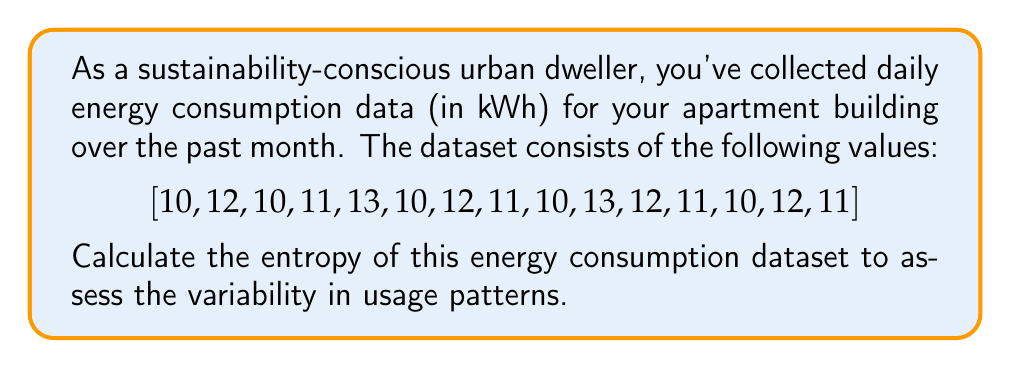Solve this math problem. To calculate the entropy of the energy consumption dataset, we'll follow these steps:

1. Count the frequency of each unique value in the dataset.
2. Calculate the probability of each unique value.
3. Apply the entropy formula.

Step 1: Frequency count
10 kWh: 5 times
11 kWh: 3 times
12 kWh: 4 times
13 kWh: 2 times

Total number of data points: 15

Step 2: Probability calculation
$p(10) = 5/15 = 1/3$
$p(11) = 3/15 = 1/5$
$p(12) = 4/15 = 4/15$
$p(13) = 2/15$

Step 3: Entropy calculation
The entropy formula is:

$$ H = -\sum_{i=1}^{n} p(x_i) \log_2(p(x_i)) $$

Where $p(x_i)$ is the probability of each unique value.

Substituting the probabilities:

$$ \begin{align*}
H &= -\left(\frac{1}{3} \log_2\left(\frac{1}{3}\right) + \frac{1}{5} \log_2\left(\frac{1}{5}\right) + \frac{4}{15} \log_2\left(\frac{4}{15}\right) + \frac{2}{15} \log_2\left(\frac{2}{15}\right)\right) \\[10pt]
&\approx -\left(0.3333 \cdot (-1.5850) + 0.2000 \cdot (-2.3219) + 0.2667 \cdot (-1.9069) + 0.1333 \cdot (-2.9069)\right) \\[10pt]
&\approx 0.5283 + 0.4644 + 0.5085 + 0.3876 \\[10pt]
&\approx 1.8888
\end{align*} $$
Answer: The entropy of the urban energy consumption dataset is approximately 1.8888 bits. 